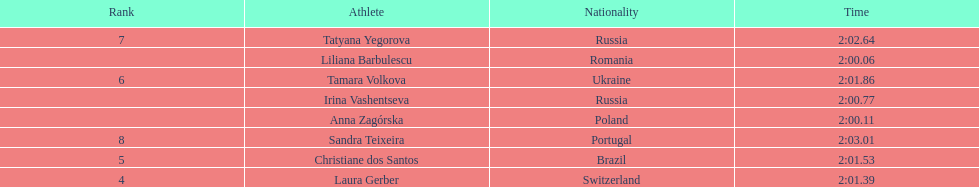Which country had the most finishers in the top 8? Russia. 